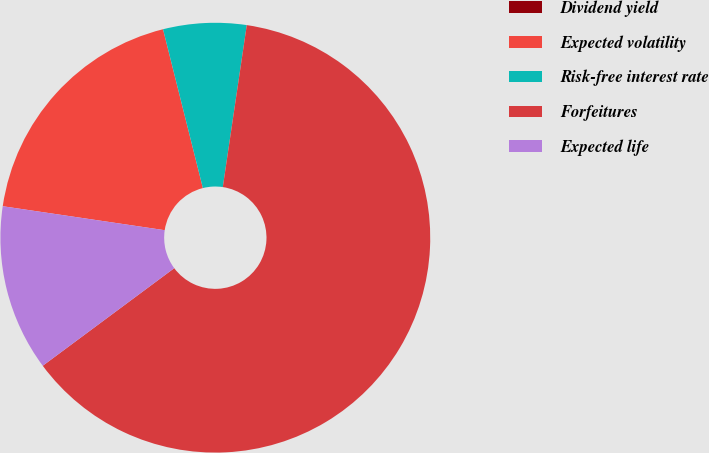Convert chart to OTSL. <chart><loc_0><loc_0><loc_500><loc_500><pie_chart><fcel>Dividend yield<fcel>Expected volatility<fcel>Risk-free interest rate<fcel>Forfeitures<fcel>Expected life<nl><fcel>0.0%<fcel>18.75%<fcel>6.25%<fcel>62.5%<fcel>12.5%<nl></chart> 